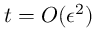Convert formula to latex. <formula><loc_0><loc_0><loc_500><loc_500>t = O ( \epsilon ^ { 2 } )</formula> 